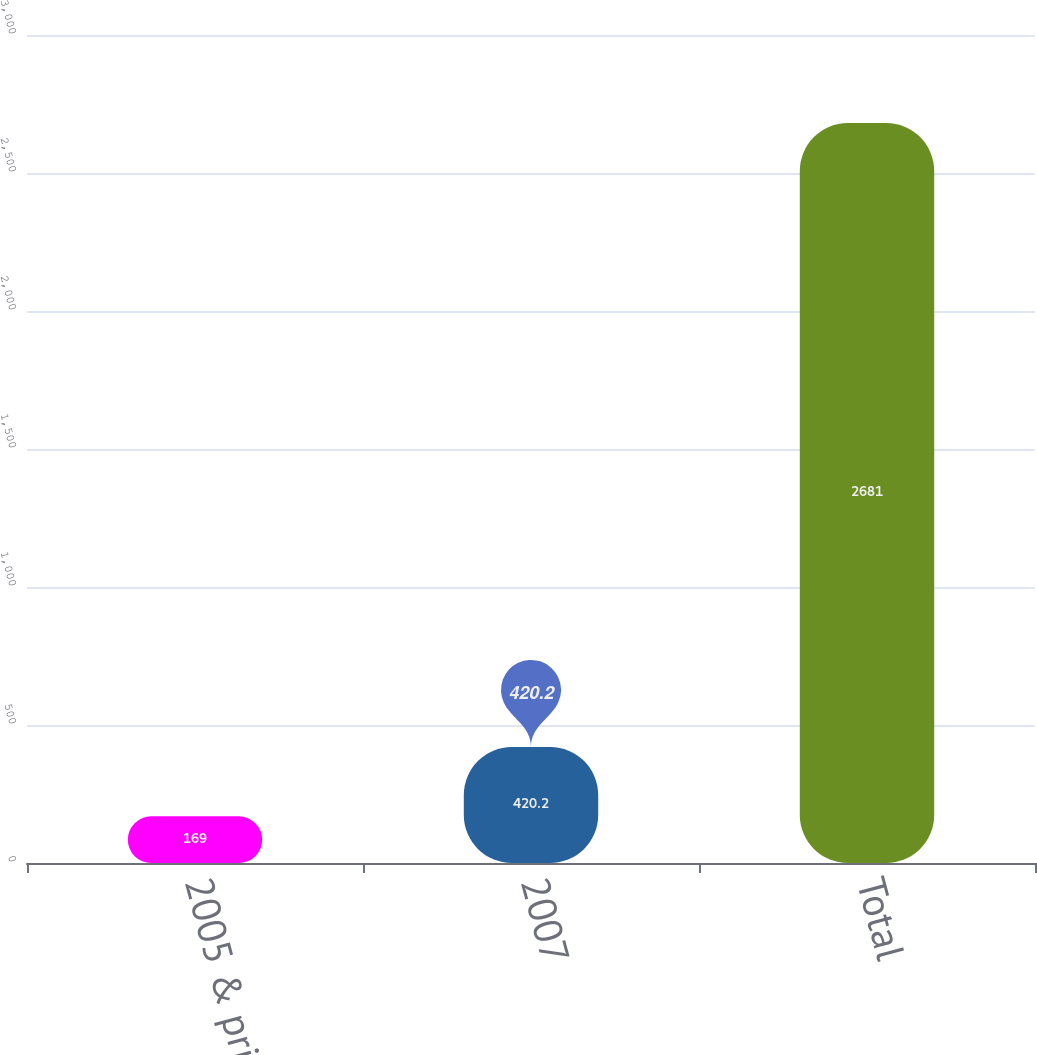Convert chart. <chart><loc_0><loc_0><loc_500><loc_500><bar_chart><fcel>2005 & prior<fcel>2007<fcel>Total<nl><fcel>169<fcel>420.2<fcel>2681<nl></chart> 